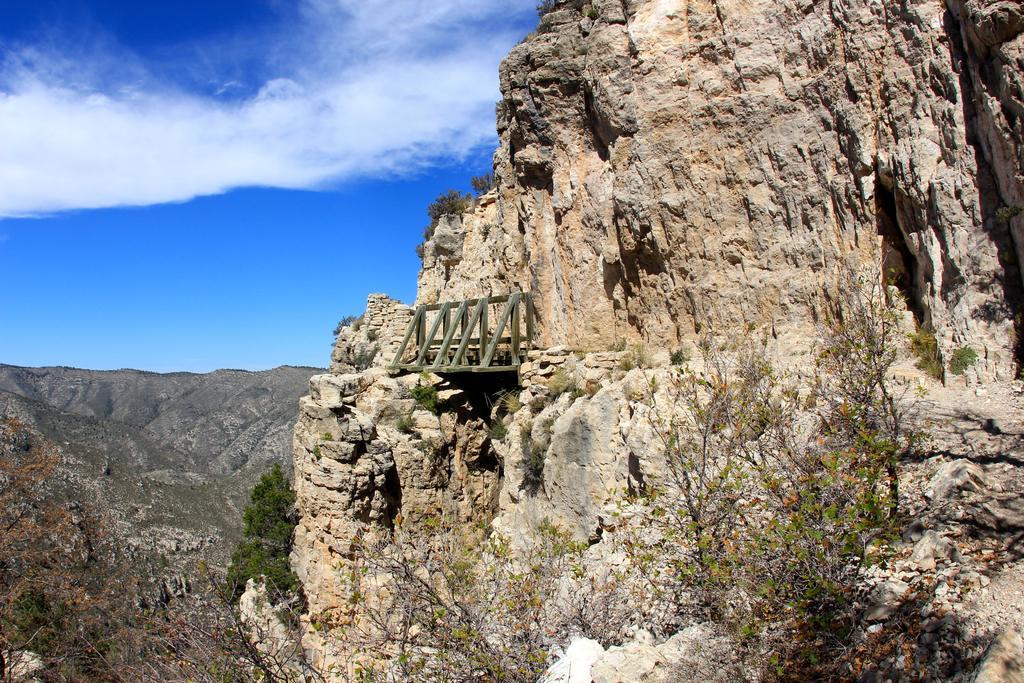Please provide a concise description of this image. In this picture we can see few trees and hills, and also we can see clouds. 